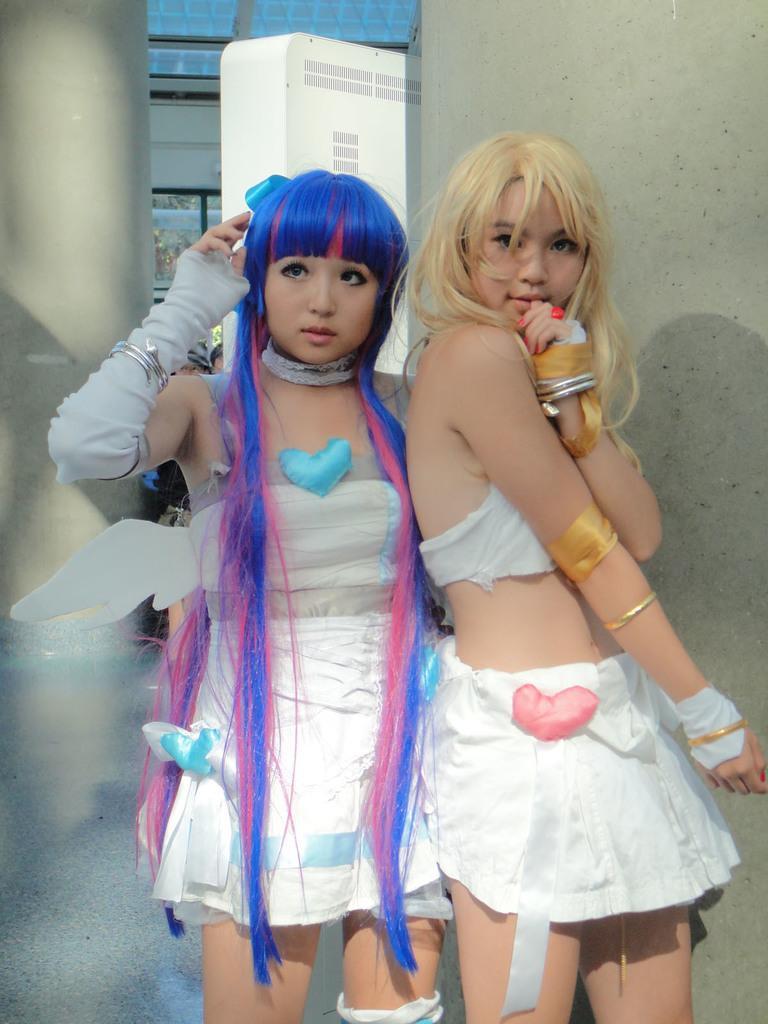How would you summarize this image in a sentence or two? In this picture there are two girl wearing white color dress, standing and giving a pose. Behind there is a grey color wall. 